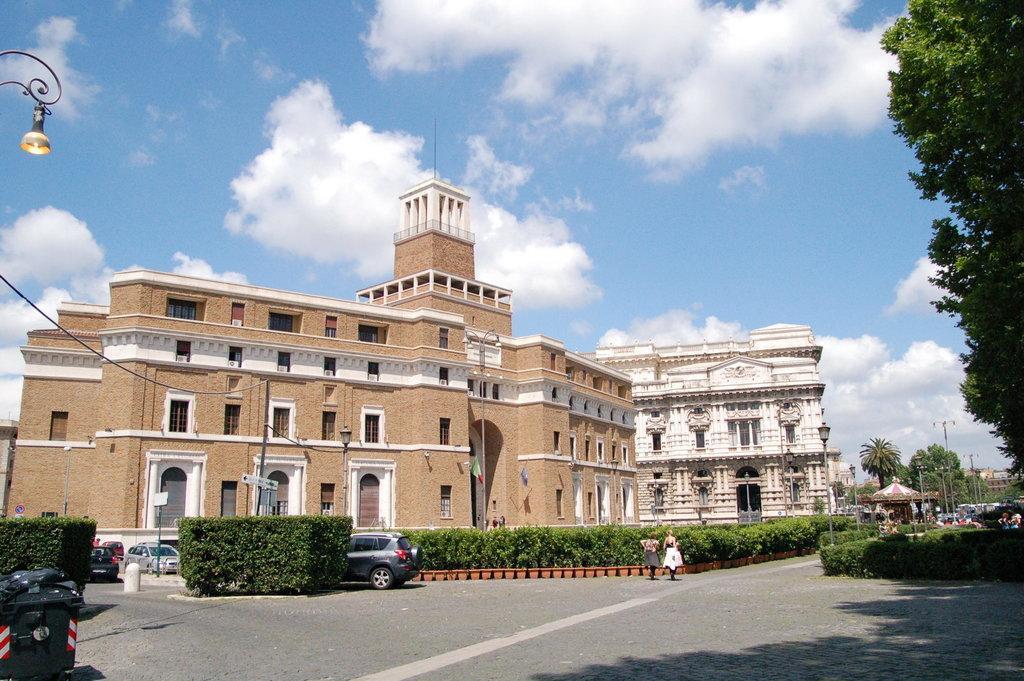Could you give a brief overview of what you see in this image? In the foreground of this picture, there is a road. In the background, we can see plants, trees, buildings, poles, vehicle on the road, person's moving on the road, sky and the cloud. 